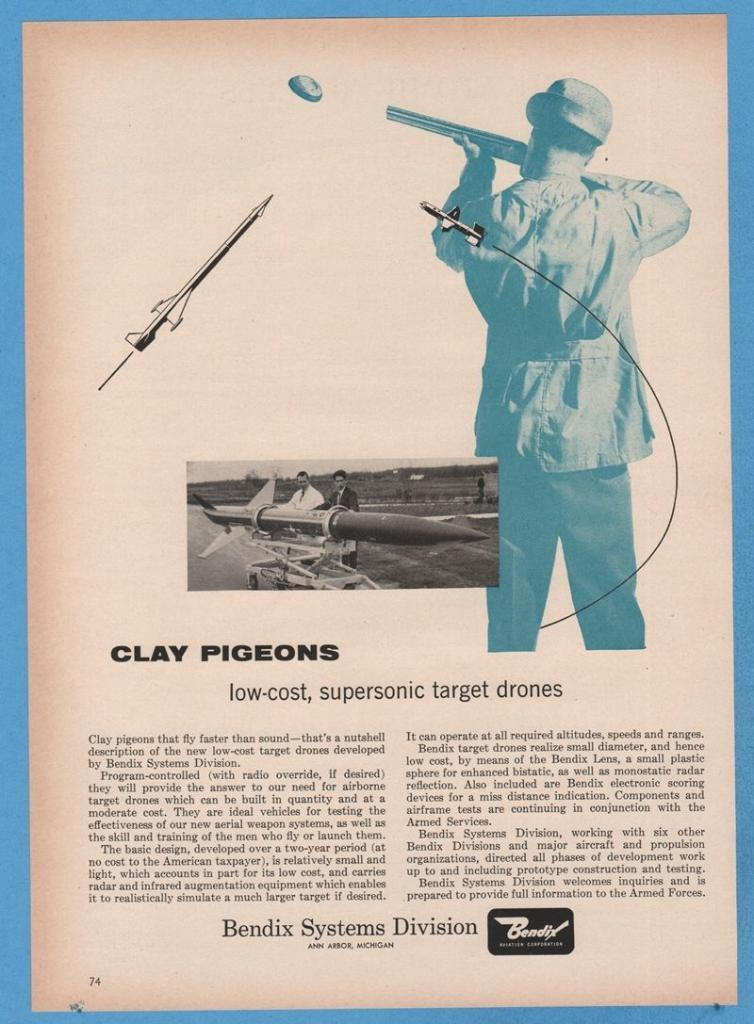What type of visual is the image? The image is a poster. What can be seen on the poster? There are people depicted on the poster, including one person holding a gun. What other objects are present on the poster? There is a rocket and various other objects on the poster. Is there any text on the poster? Yes, there is text on the poster. Can you tell me how many cords are connected to the rocket on the poster? There are no cords connected to the rocket on the poster; it is depicted as a standalone object. What statement is being made by the person holding the gun on the poster? The image is a poster and does not convey a specific statement; it is a visual representation of various elements. 